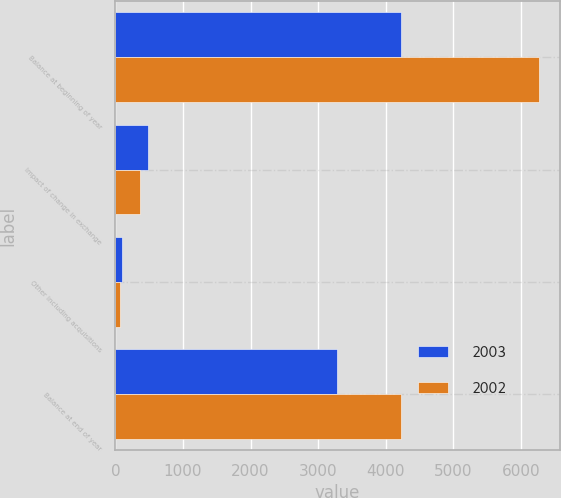<chart> <loc_0><loc_0><loc_500><loc_500><stacked_bar_chart><ecel><fcel>Balance at beginning of year<fcel>Impact of change in exchange<fcel>Other including acquisitions<fcel>Balance at end of year<nl><fcel>2003<fcel>4230<fcel>488<fcel>100<fcel>3284<nl><fcel>2002<fcel>6261<fcel>370<fcel>62<fcel>4230<nl></chart> 